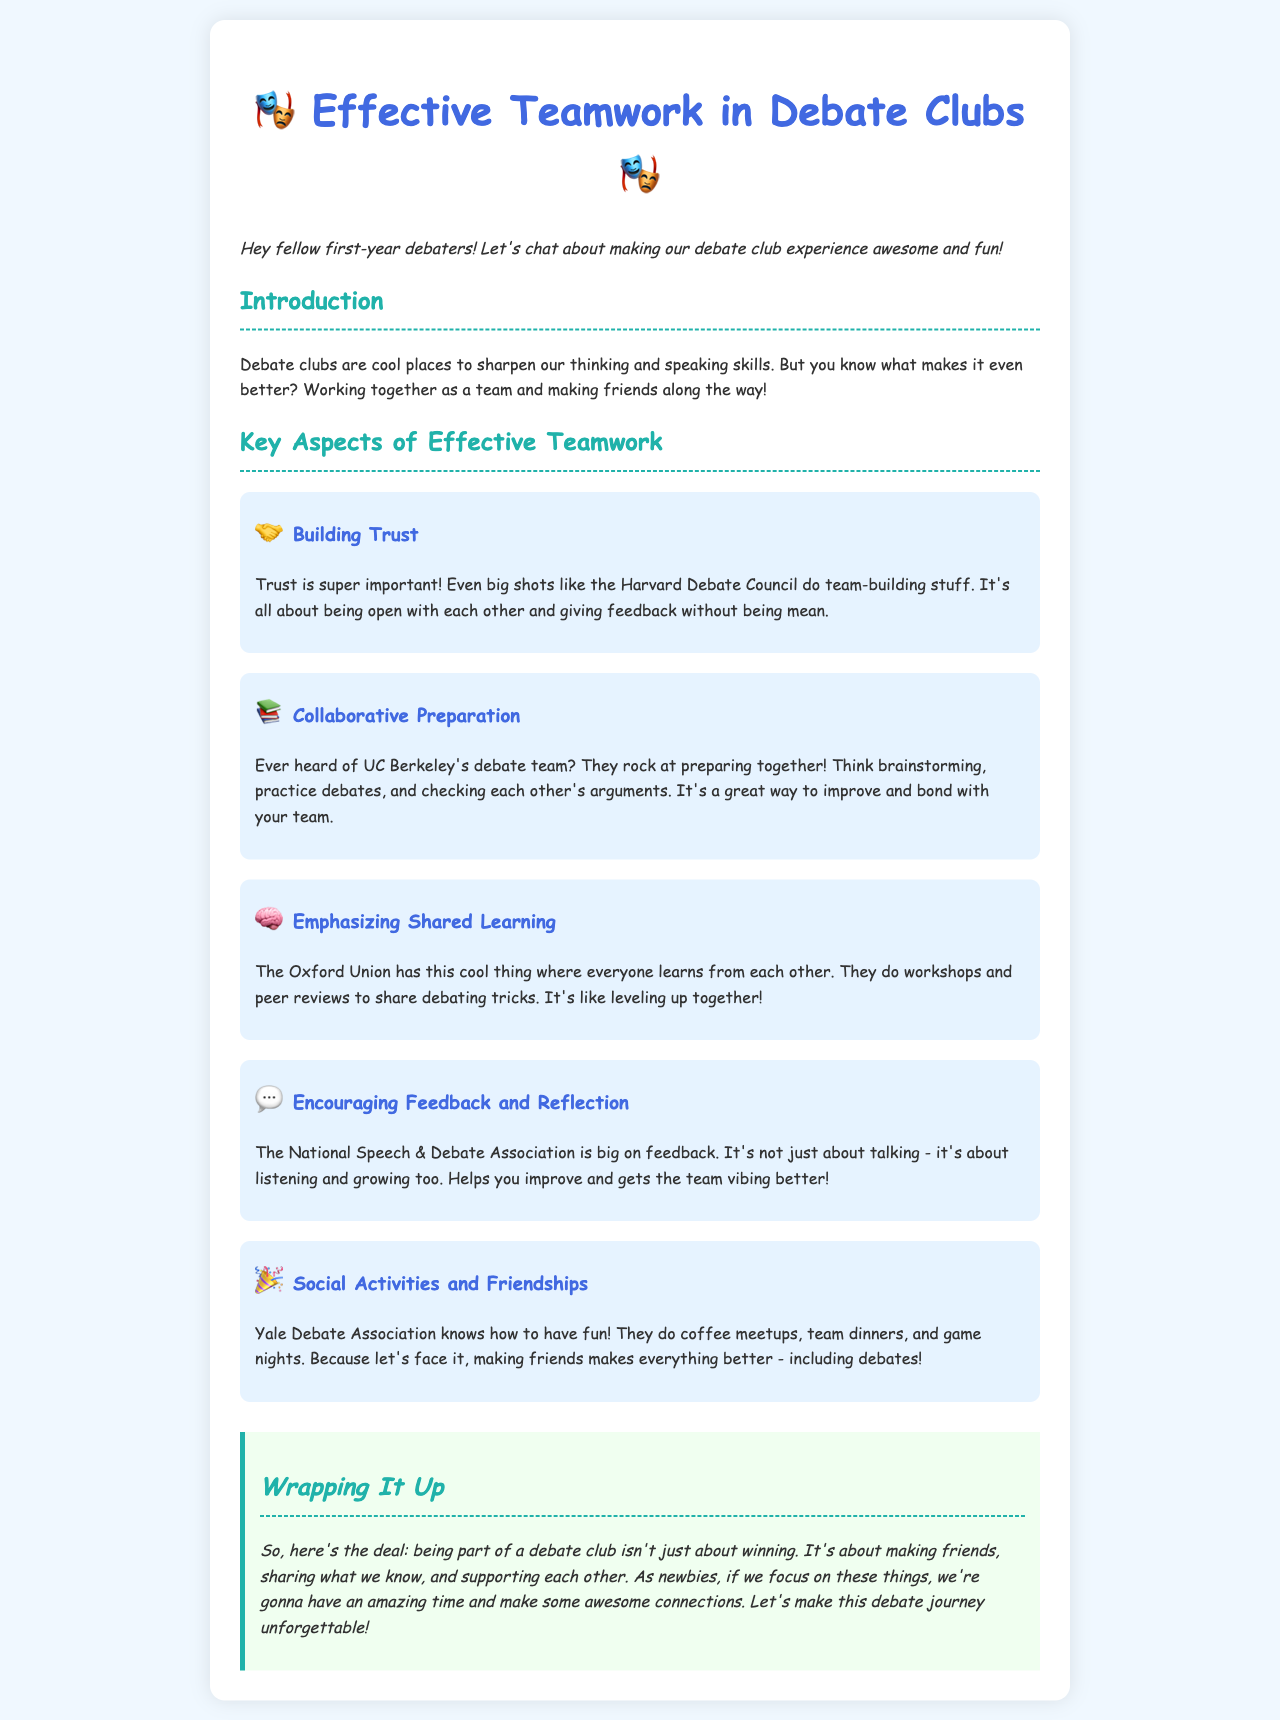What is the title of the document? The title of the document appears at the top of the rendered document, stating the main topic it covers, which is about teamwork in debate clubs.
Answer: Effective Teamwork in Debate Clubs Who is the primary audience of the document? The document's introductory statement indicates that it targets first-year debaters, making them the primary audience.
Answer: first-year debaters Which debate club is mentioned for its team-building activities? The document cites the Harvard Debate Council as an example of a club that engages in team-building activities.
Answer: Harvard Debate Council What social activity does the Yale Debate Association organize? The document mentions various social activities organized by the Yale Debate Association, including coffee meetups and game nights.
Answer: coffee meetups What is emphasized as important for effective teamwork in debates? The document highlights multiple aspects that contribute to effective teamwork, including feedback and reflection among team members.
Answer: feedback and reflection How does the Oxford Union facilitate shared learning? The document states that the Oxford Union conducts workshops and peer reviews to promote shared learning among its members.
Answer: workshops and peer reviews What is one of the key aspects of effective teamwork highlighted in the document? The document identifies building trust as one of the crucial aspects needed for effective teamwork in debate clubs.
Answer: Building Trust What is the concluding message of the document? The conclusion emphasizes the value of making friends and supporting each other rather than just focusing on winning in debate clubs.
Answer: making friends and supporting each other 